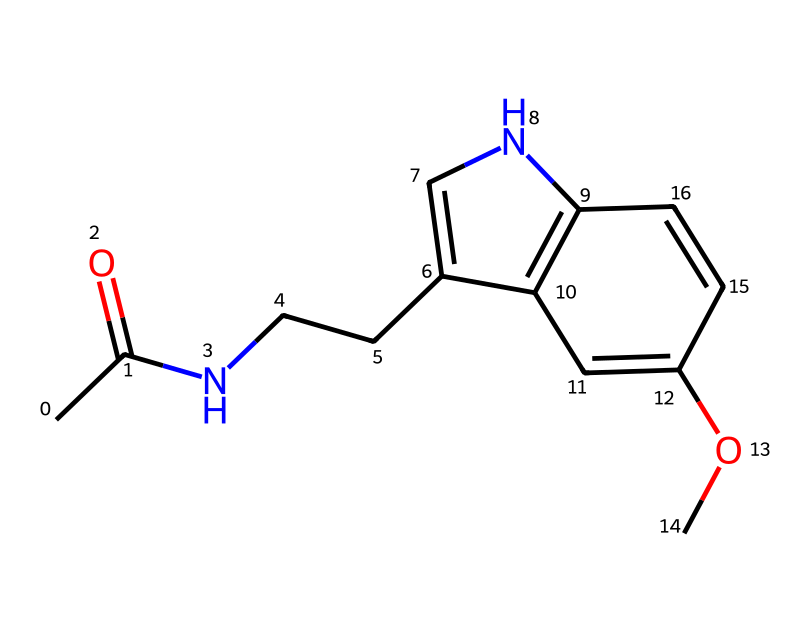What is the molecular formula of this compound? To determine the molecular formula, we need to count the number of each type of atom present in the SMILES representation. From the structure represented in the SMILES, we can identify that there are 13 carbons (C), 16 hydrogens (H), 2 nitrogens (N), and 2 oxygens (O). Thus, the molecular formula is C13H16N2O2.
Answer: C13H16N2O2 How many nitrogen atoms are present in the structure? By examining the SMILES representation, we can locate the nitrogen atoms marked by 'N'. There are two instances of 'N', indicating there are two nitrogen atoms in the chemical structure.
Answer: 2 What functional groups are present in melatonin? In the structure, we can identify a carbonyl group (C=O) from the acetyl group (indicated by CC(=O)), as well as an ether group (–O–) from the methoxy (–OCH3) substitution. These are the two main functional groups present in melatonin.
Answer: carbonyl and ether Is melatonin a polar or non-polar molecule? To determine polarity, we consider the presence of polar functional groups such as the carbonyl and the methoxy group, alongside the overall molecular structure's symmetry. The presence of a nitrogen and an oxygen can contribute to the molecule being polar, but due to the overall structure and the balance of functional groups, melatonin is generally considered a moderately polar molecule.
Answer: moderately polar What type of chemical is melatonin classified as? Since melatonin is a small organic molecule that does not disassociate into ions in solution, it is classified as a non-electrolyte. This classification is based on its molecular structure, which lacks free ions, and its behavior in solution.
Answer: non-electrolyte 